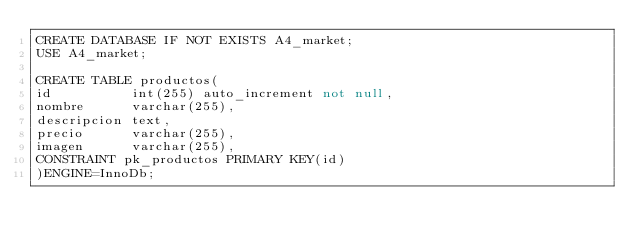<code> <loc_0><loc_0><loc_500><loc_500><_SQL_>CREATE DATABASE IF NOT EXISTS A4_market;
USE A4_market;

CREATE TABLE productos(
id			int(255) auto_increment not null,
nombre 		varchar(255),
descripcion text,
precio		varchar(255),
imagen		varchar(255),
CONSTRAINT pk_productos PRIMARY KEY(id)
)ENGINE=InnoDb;
</code> 